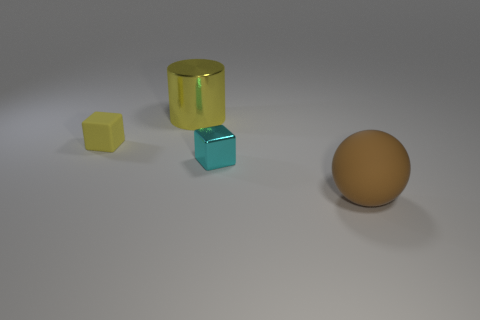Add 2 purple rubber balls. How many objects exist? 6 Subtract all cylinders. How many objects are left? 3 Add 2 small matte cubes. How many small matte cubes are left? 3 Add 4 rubber cylinders. How many rubber cylinders exist? 4 Subtract 0 purple spheres. How many objects are left? 4 Subtract all large brown cylinders. Subtract all tiny cyan metallic blocks. How many objects are left? 3 